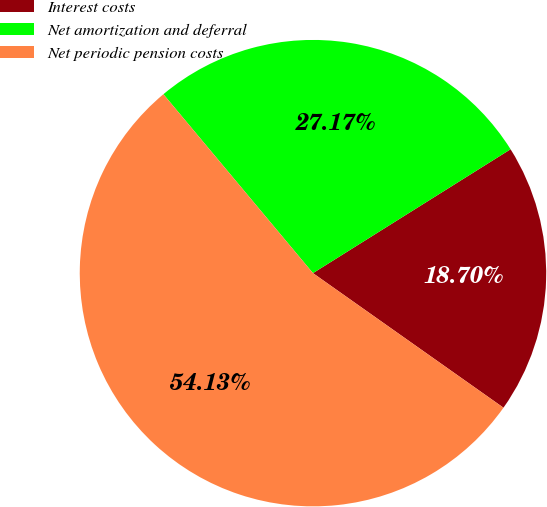Convert chart. <chart><loc_0><loc_0><loc_500><loc_500><pie_chart><fcel>Interest costs<fcel>Net amortization and deferral<fcel>Net periodic pension costs<nl><fcel>18.7%<fcel>27.17%<fcel>54.13%<nl></chart> 